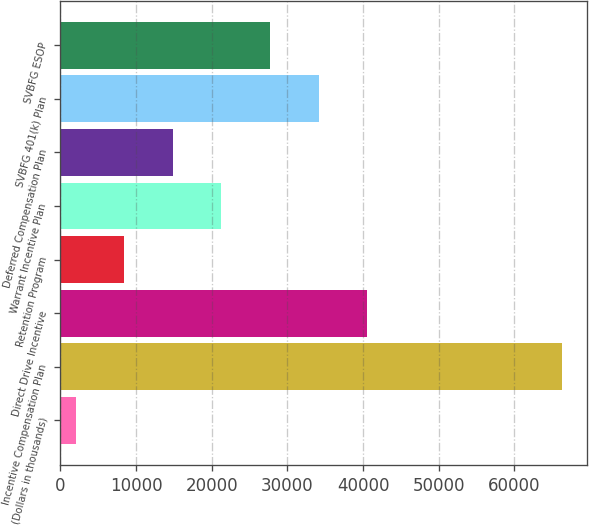Convert chart to OTSL. <chart><loc_0><loc_0><loc_500><loc_500><bar_chart><fcel>(Dollars in thousands)<fcel>Incentive Compensation Plan<fcel>Direct Drive Incentive<fcel>Retention Program<fcel>Warrant Incentive Plan<fcel>Deferred Compensation Plan<fcel>SVBFG 401(k) Plan<fcel>SVBFG ESOP<nl><fcel>2013<fcel>66232<fcel>40544.4<fcel>8434.9<fcel>21278.7<fcel>14856.8<fcel>34122.5<fcel>27700.6<nl></chart> 